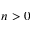<formula> <loc_0><loc_0><loc_500><loc_500>n > 0</formula> 